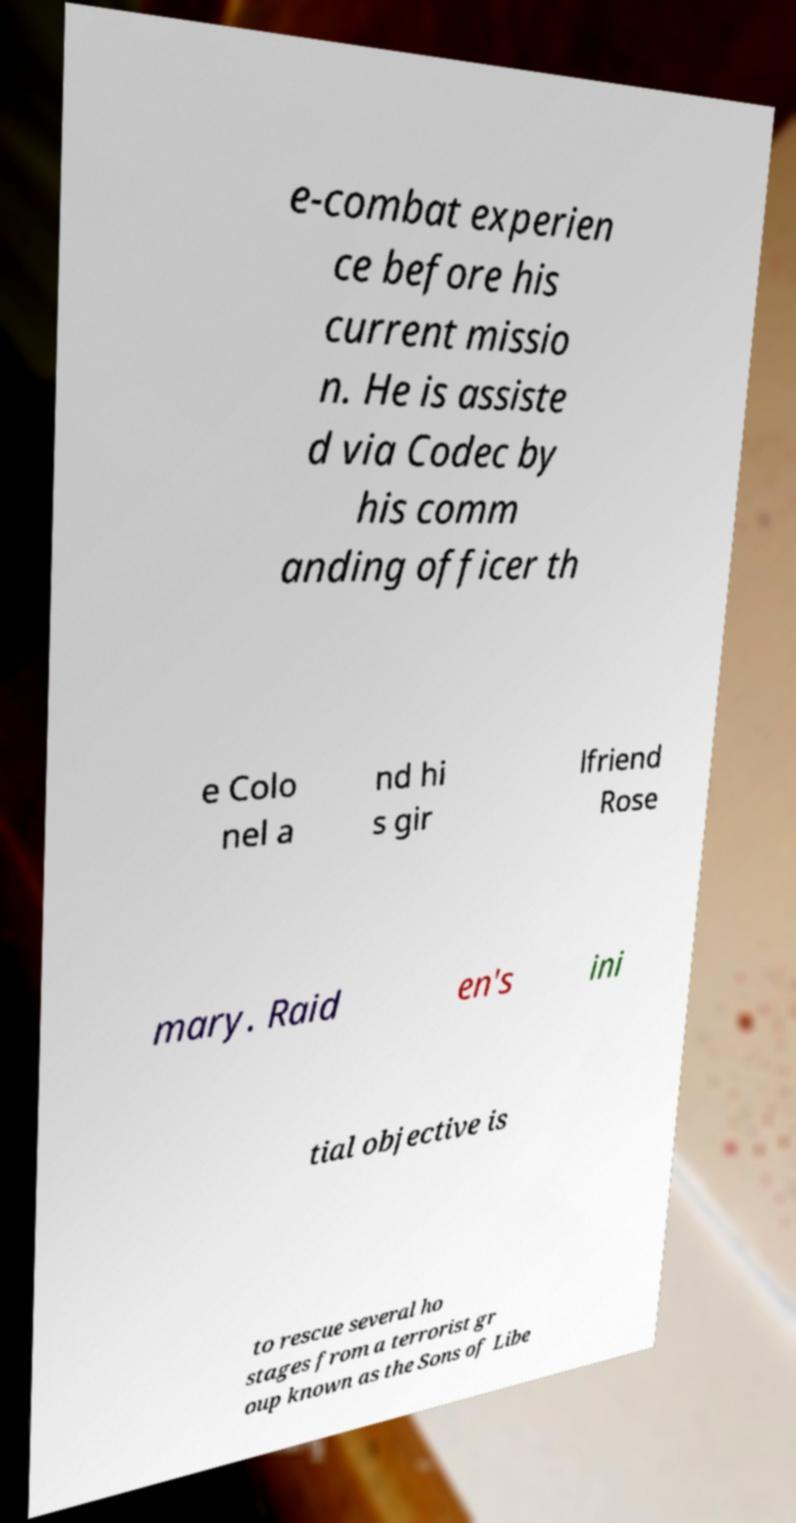I need the written content from this picture converted into text. Can you do that? e-combat experien ce before his current missio n. He is assiste d via Codec by his comm anding officer th e Colo nel a nd hi s gir lfriend Rose mary. Raid en's ini tial objective is to rescue several ho stages from a terrorist gr oup known as the Sons of Libe 